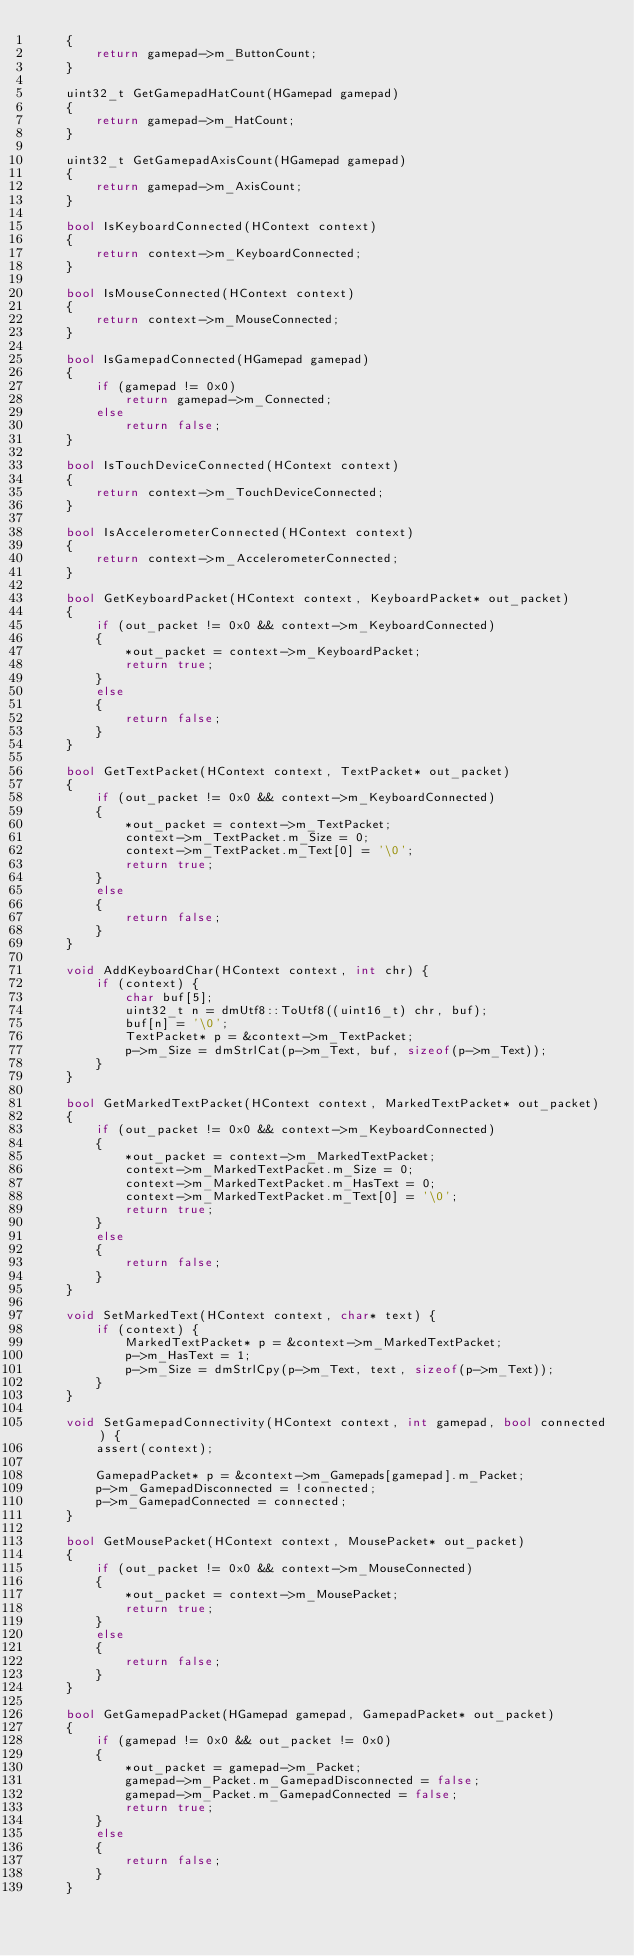Convert code to text. <code><loc_0><loc_0><loc_500><loc_500><_C++_>    {
        return gamepad->m_ButtonCount;
    }

    uint32_t GetGamepadHatCount(HGamepad gamepad)
    {
        return gamepad->m_HatCount;
    }

    uint32_t GetGamepadAxisCount(HGamepad gamepad)
    {
        return gamepad->m_AxisCount;
    }

    bool IsKeyboardConnected(HContext context)
    {
        return context->m_KeyboardConnected;
    }

    bool IsMouseConnected(HContext context)
    {
        return context->m_MouseConnected;
    }

    bool IsGamepadConnected(HGamepad gamepad)
    {
        if (gamepad != 0x0)
            return gamepad->m_Connected;
        else
            return false;
    }

    bool IsTouchDeviceConnected(HContext context)
    {
        return context->m_TouchDeviceConnected;
    }

    bool IsAccelerometerConnected(HContext context)
    {
        return context->m_AccelerometerConnected;
    }

    bool GetKeyboardPacket(HContext context, KeyboardPacket* out_packet)
    {
        if (out_packet != 0x0 && context->m_KeyboardConnected)
        {
            *out_packet = context->m_KeyboardPacket;
            return true;
        }
        else
        {
            return false;
        }
    }

    bool GetTextPacket(HContext context, TextPacket* out_packet)
    {
        if (out_packet != 0x0 && context->m_KeyboardConnected)
        {
            *out_packet = context->m_TextPacket;
            context->m_TextPacket.m_Size = 0;
            context->m_TextPacket.m_Text[0] = '\0';
            return true;
        }
        else
        {
            return false;
        }
    }

    void AddKeyboardChar(HContext context, int chr) {
        if (context) {
            char buf[5];
            uint32_t n = dmUtf8::ToUtf8((uint16_t) chr, buf);
            buf[n] = '\0';
            TextPacket* p = &context->m_TextPacket;
            p->m_Size = dmStrlCat(p->m_Text, buf, sizeof(p->m_Text));
        }
    }

    bool GetMarkedTextPacket(HContext context, MarkedTextPacket* out_packet)
    {
        if (out_packet != 0x0 && context->m_KeyboardConnected)
        {
            *out_packet = context->m_MarkedTextPacket;
            context->m_MarkedTextPacket.m_Size = 0;
            context->m_MarkedTextPacket.m_HasText = 0;
            context->m_MarkedTextPacket.m_Text[0] = '\0';
            return true;
        }
        else
        {
            return false;
        }
    }

    void SetMarkedText(HContext context, char* text) {
        if (context) {
            MarkedTextPacket* p = &context->m_MarkedTextPacket;
            p->m_HasText = 1;
            p->m_Size = dmStrlCpy(p->m_Text, text, sizeof(p->m_Text));
        }
    }

    void SetGamepadConnectivity(HContext context, int gamepad, bool connected) {
        assert(context);

        GamepadPacket* p = &context->m_Gamepads[gamepad].m_Packet;
        p->m_GamepadDisconnected = !connected;
        p->m_GamepadConnected = connected;
    }

    bool GetMousePacket(HContext context, MousePacket* out_packet)
    {
        if (out_packet != 0x0 && context->m_MouseConnected)
        {
            *out_packet = context->m_MousePacket;
            return true;
        }
        else
        {
            return false;
        }
    }

    bool GetGamepadPacket(HGamepad gamepad, GamepadPacket* out_packet)
    {
        if (gamepad != 0x0 && out_packet != 0x0)
        {
            *out_packet = gamepad->m_Packet;
            gamepad->m_Packet.m_GamepadDisconnected = false;
            gamepad->m_Packet.m_GamepadConnected = false;
            return true;
        }
        else
        {
            return false;
        }
    }
</code> 